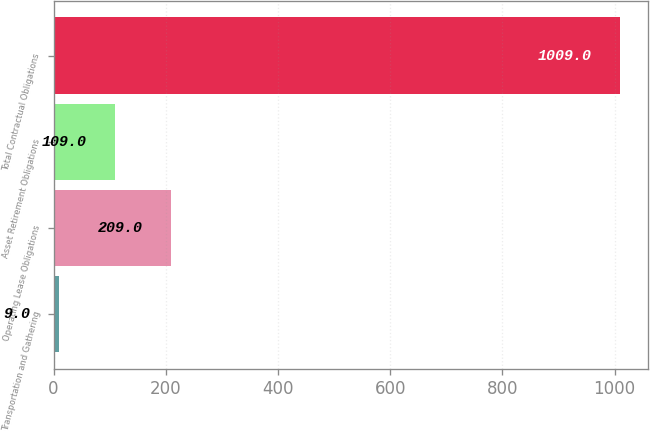Convert chart to OTSL. <chart><loc_0><loc_0><loc_500><loc_500><bar_chart><fcel>Transportation and Gathering<fcel>Operating Lease Obligations<fcel>Asset Retirement Obligations<fcel>Total Contractual Obligations<nl><fcel>9<fcel>209<fcel>109<fcel>1009<nl></chart> 